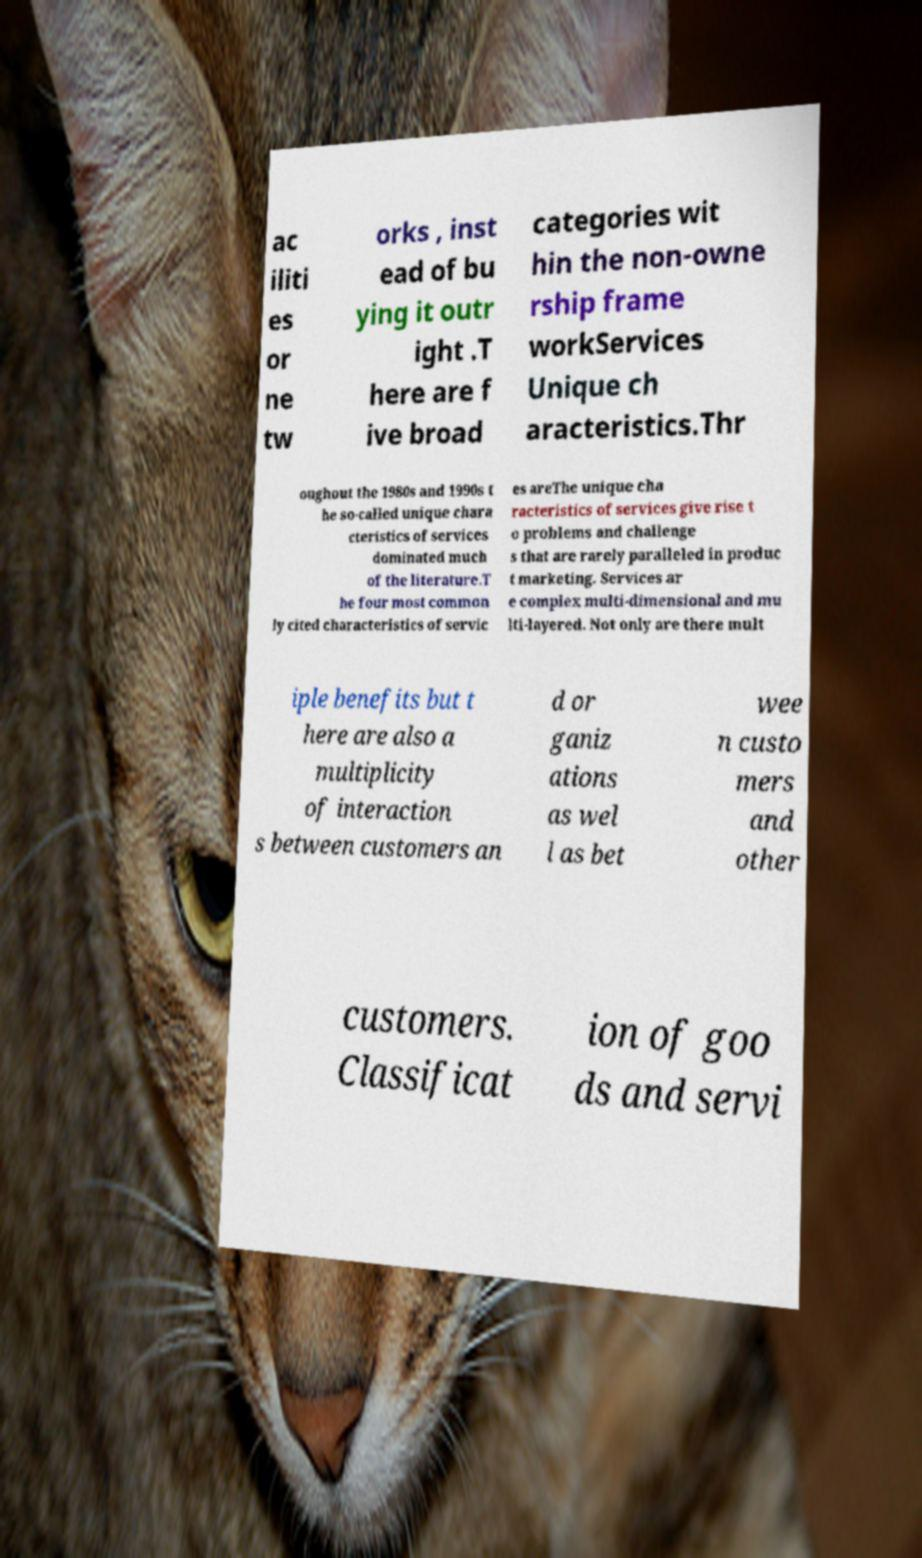Can you read and provide the text displayed in the image?This photo seems to have some interesting text. Can you extract and type it out for me? ac iliti es or ne tw orks , inst ead of bu ying it outr ight .T here are f ive broad categories wit hin the non-owne rship frame workServices Unique ch aracteristics.Thr oughout the 1980s and 1990s t he so-called unique chara cteristics of services dominated much of the literature.T he four most common ly cited characteristics of servic es areThe unique cha racteristics of services give rise t o problems and challenge s that are rarely paralleled in produc t marketing. Services ar e complex multi-dimensional and mu lti-layered. Not only are there mult iple benefits but t here are also a multiplicity of interaction s between customers an d or ganiz ations as wel l as bet wee n custo mers and other customers. Classificat ion of goo ds and servi 